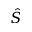<formula> <loc_0><loc_0><loc_500><loc_500>\hat { S }</formula> 